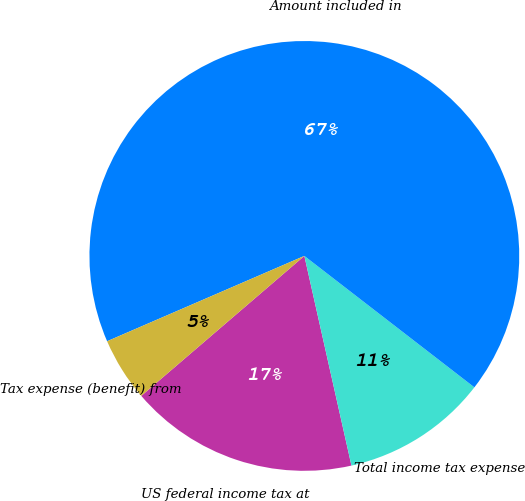Convert chart to OTSL. <chart><loc_0><loc_0><loc_500><loc_500><pie_chart><fcel>US federal income tax at<fcel>Total income tax expense<fcel>Amount included in<fcel>Tax expense (benefit) from<nl><fcel>17.23%<fcel>11.01%<fcel>66.97%<fcel>4.79%<nl></chart> 